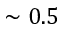<formula> <loc_0><loc_0><loc_500><loc_500>\sim 0 . 5</formula> 